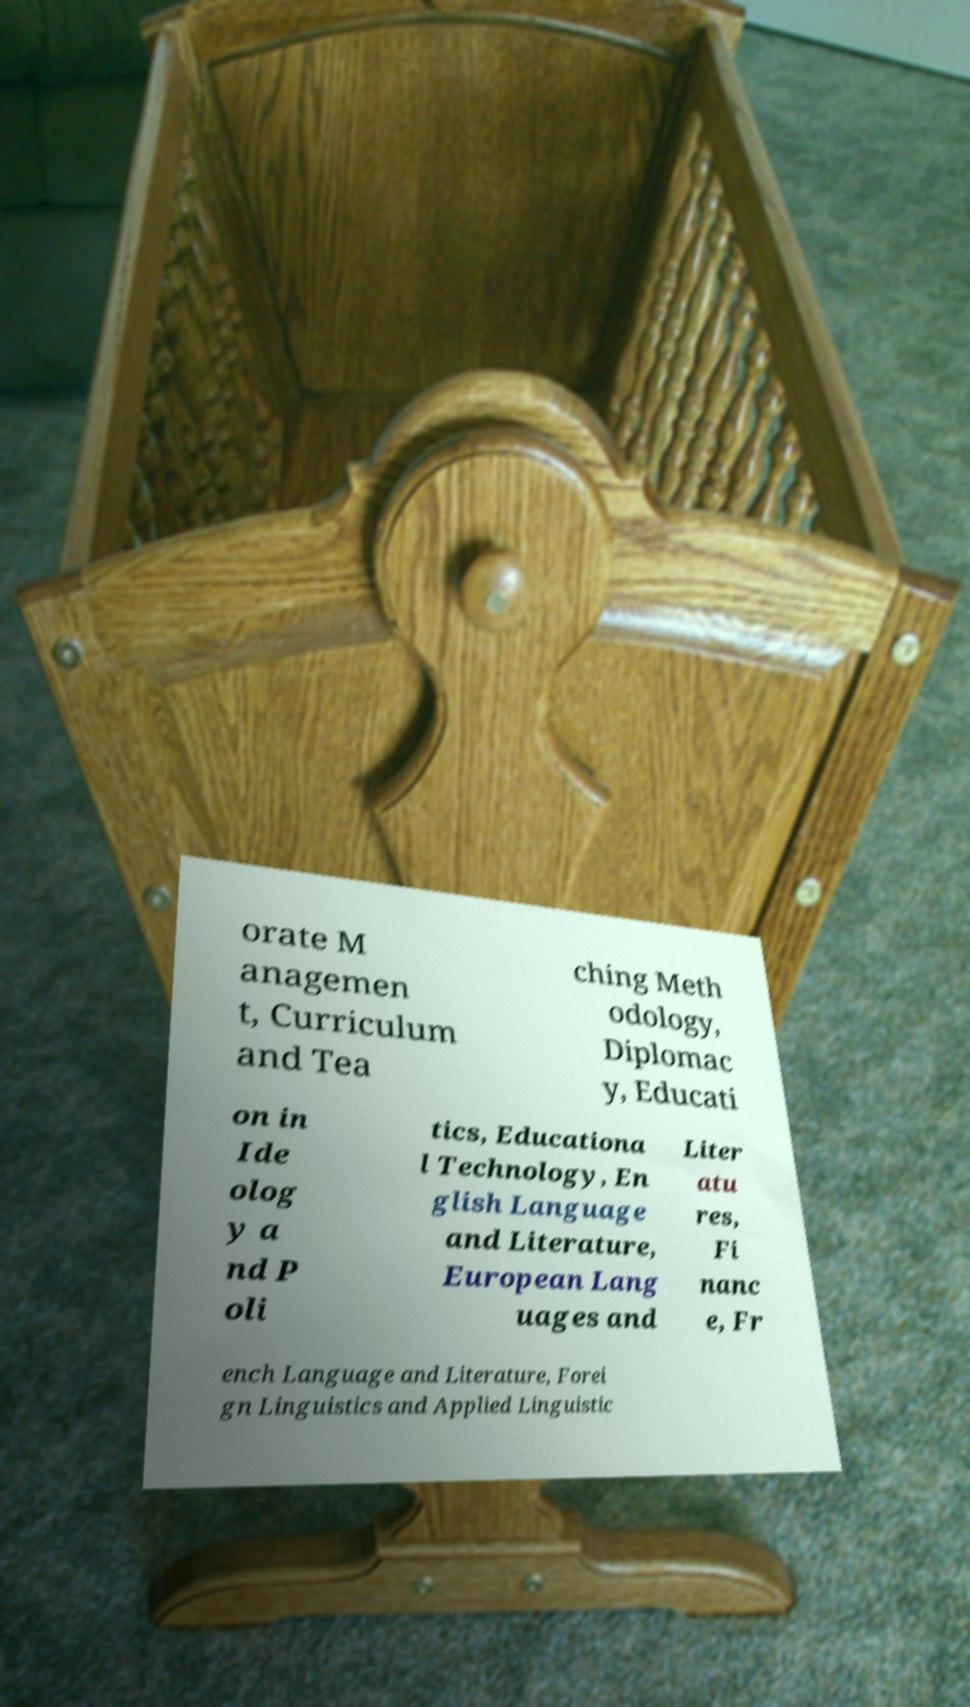I need the written content from this picture converted into text. Can you do that? orate M anagemen t, Curriculum and Tea ching Meth odology, Diplomac y, Educati on in Ide olog y a nd P oli tics, Educationa l Technology, En glish Language and Literature, European Lang uages and Liter atu res, Fi nanc e, Fr ench Language and Literature, Forei gn Linguistics and Applied Linguistic 